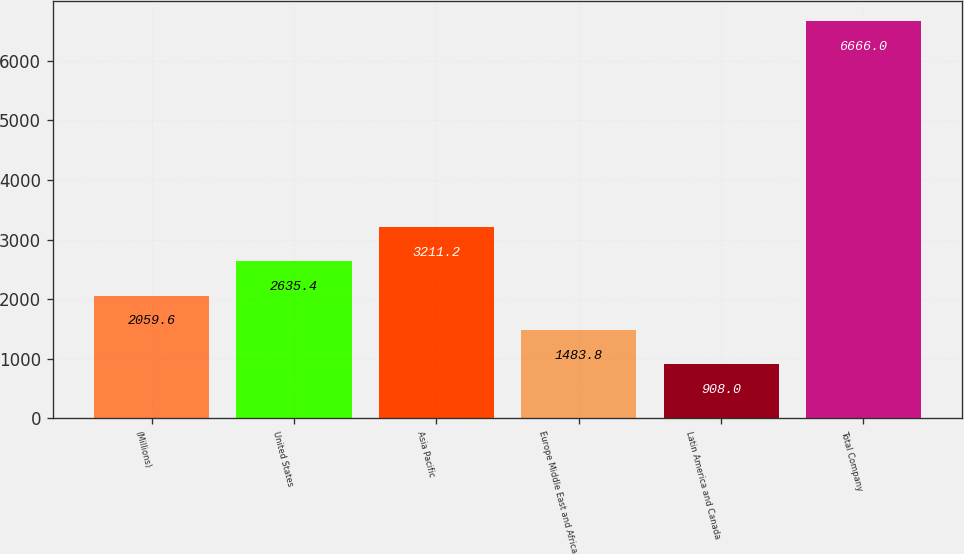Convert chart. <chart><loc_0><loc_0><loc_500><loc_500><bar_chart><fcel>(Millions)<fcel>United States<fcel>Asia Pacific<fcel>Europe Middle East and Africa<fcel>Latin America and Canada<fcel>Total Company<nl><fcel>2059.6<fcel>2635.4<fcel>3211.2<fcel>1483.8<fcel>908<fcel>6666<nl></chart> 